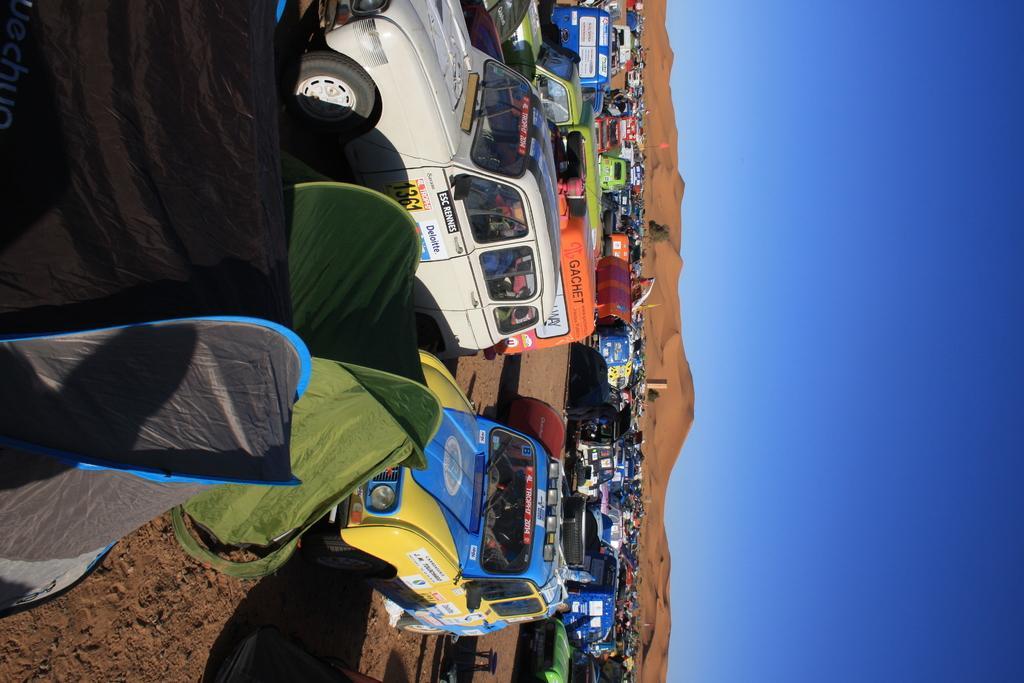In one or two sentences, can you explain what this image depicts? In this image, I can see vehicles and tents. On the right side of the image, there is sand and the sky. 